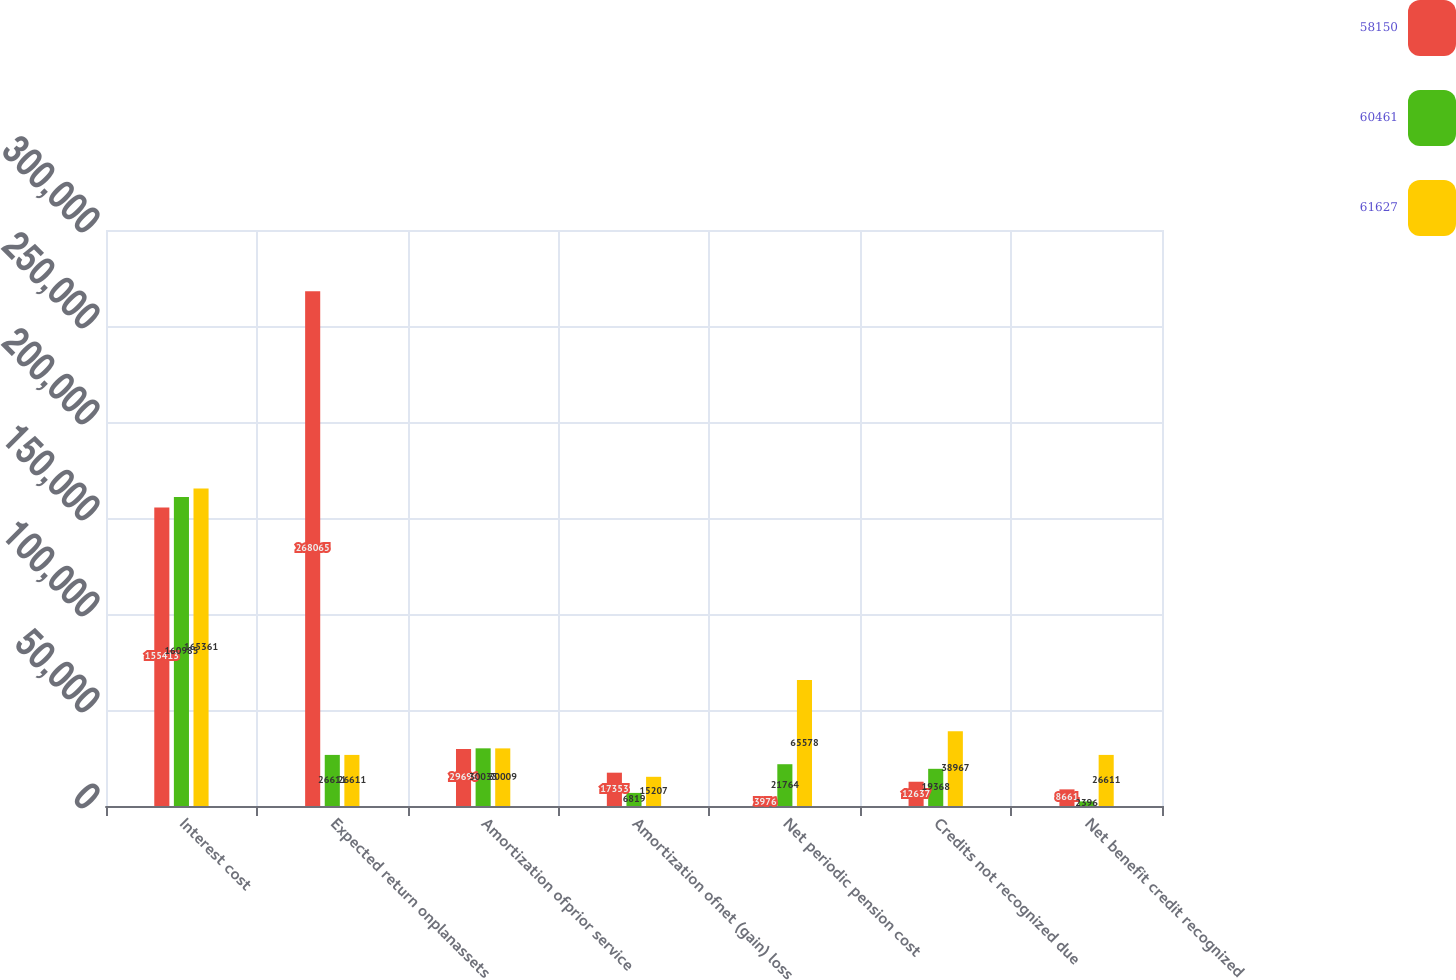<chart> <loc_0><loc_0><loc_500><loc_500><stacked_bar_chart><ecel><fcel>Interest cost<fcel>Expected return onplanassets<fcel>Amortization ofprior service<fcel>Amortization ofnet (gain) loss<fcel>Net periodic pension cost<fcel>Credits not recognized due<fcel>Net benefit credit recognized<nl><fcel>58150<fcel>155413<fcel>268065<fcel>29696<fcel>17353<fcel>3976<fcel>12637<fcel>8661<nl><fcel>60461<fcel>160985<fcel>26611<fcel>30035<fcel>6819<fcel>21764<fcel>19368<fcel>2396<nl><fcel>61627<fcel>165361<fcel>26611<fcel>30009<fcel>15207<fcel>65578<fcel>38967<fcel>26611<nl></chart> 